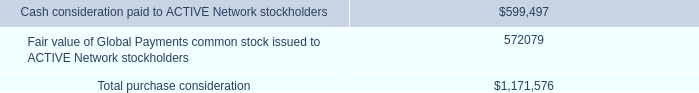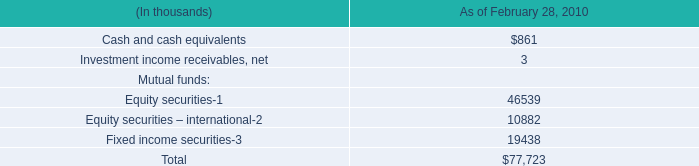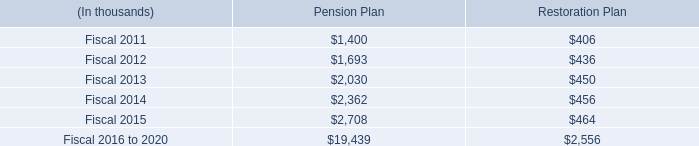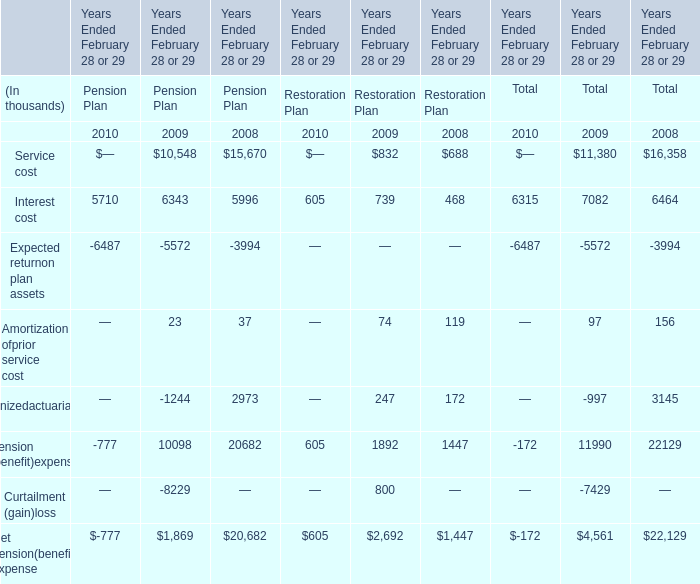What was the total amount of the Amortization ofprior service cost in the years where Amortization ofprior service cost greater than 90? (in thousand) 
Computations: (97 + 156)
Answer: 253.0. 